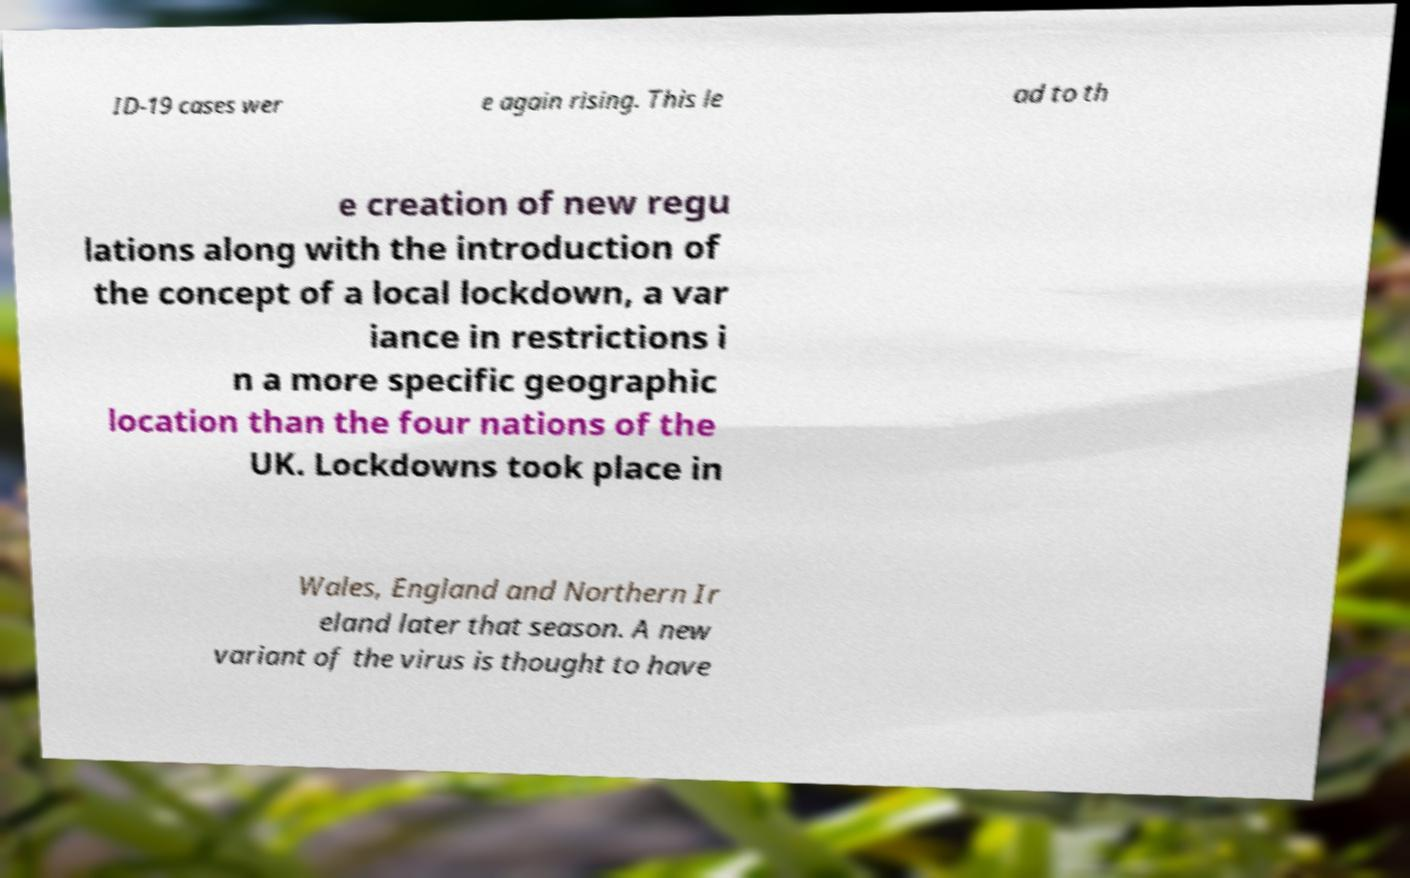Can you read and provide the text displayed in the image?This photo seems to have some interesting text. Can you extract and type it out for me? ID-19 cases wer e again rising. This le ad to th e creation of new regu lations along with the introduction of the concept of a local lockdown, a var iance in restrictions i n a more specific geographic location than the four nations of the UK. Lockdowns took place in Wales, England and Northern Ir eland later that season. A new variant of the virus is thought to have 